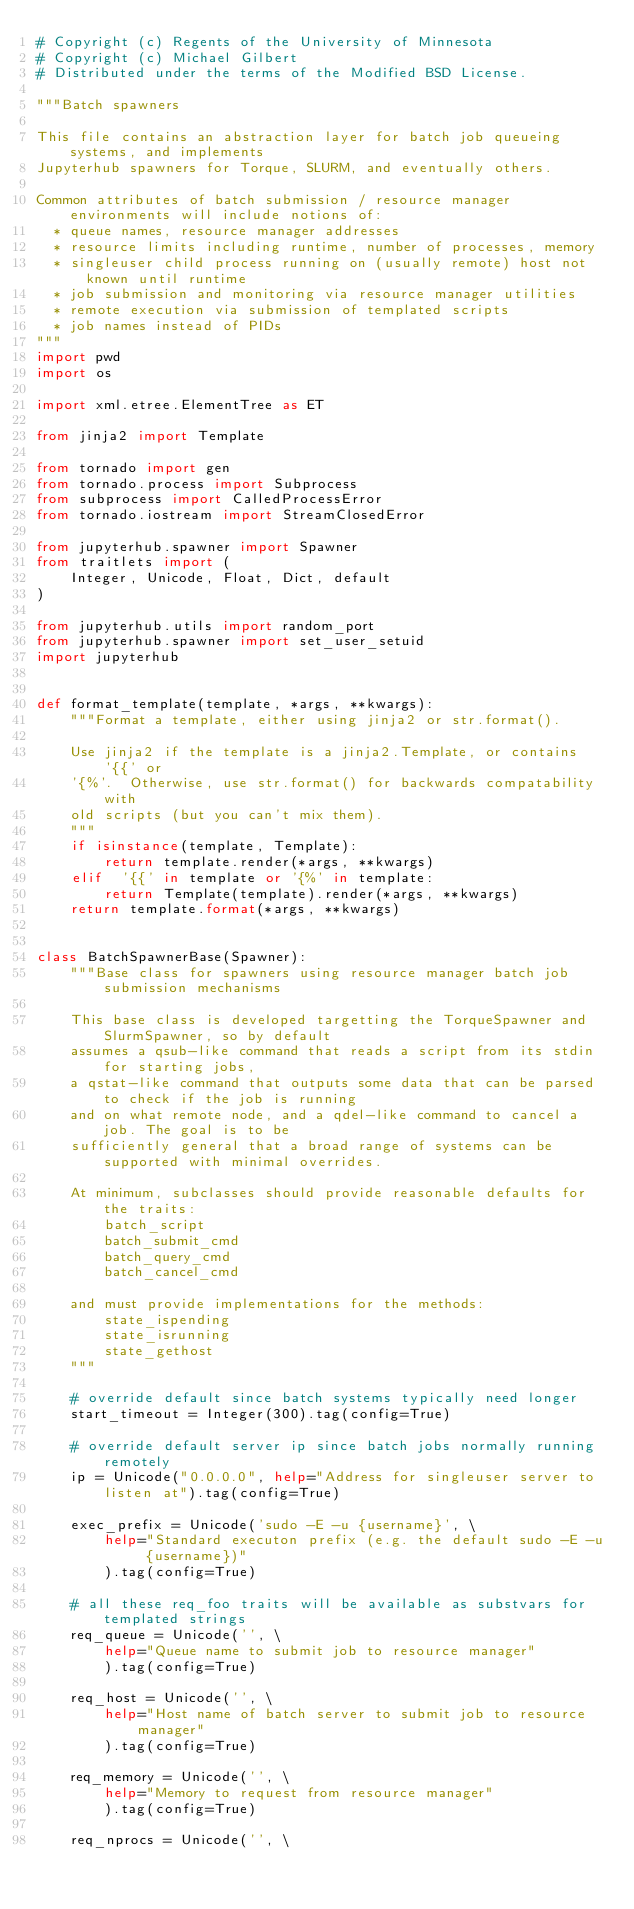<code> <loc_0><loc_0><loc_500><loc_500><_Python_># Copyright (c) Regents of the University of Minnesota
# Copyright (c) Michael Gilbert
# Distributed under the terms of the Modified BSD License.

"""Batch spawners

This file contains an abstraction layer for batch job queueing systems, and implements
Jupyterhub spawners for Torque, SLURM, and eventually others.

Common attributes of batch submission / resource manager environments will include notions of:
  * queue names, resource manager addresses
  * resource limits including runtime, number of processes, memory
  * singleuser child process running on (usually remote) host not known until runtime
  * job submission and monitoring via resource manager utilities
  * remote execution via submission of templated scripts
  * job names instead of PIDs
"""
import pwd
import os

import xml.etree.ElementTree as ET

from jinja2 import Template

from tornado import gen
from tornado.process import Subprocess
from subprocess import CalledProcessError
from tornado.iostream import StreamClosedError

from jupyterhub.spawner import Spawner
from traitlets import (
    Integer, Unicode, Float, Dict, default
)

from jupyterhub.utils import random_port
from jupyterhub.spawner import set_user_setuid
import jupyterhub


def format_template(template, *args, **kwargs):
    """Format a template, either using jinja2 or str.format().

    Use jinja2 if the template is a jinja2.Template, or contains '{{' or
    '{%'.  Otherwise, use str.format() for backwards compatability with
    old scripts (but you can't mix them).
    """
    if isinstance(template, Template):
        return template.render(*args, **kwargs)
    elif  '{{' in template or '{%' in template:
        return Template(template).render(*args, **kwargs)
    return template.format(*args, **kwargs)


class BatchSpawnerBase(Spawner):
    """Base class for spawners using resource manager batch job submission mechanisms

    This base class is developed targetting the TorqueSpawner and SlurmSpawner, so by default
    assumes a qsub-like command that reads a script from its stdin for starting jobs,
    a qstat-like command that outputs some data that can be parsed to check if the job is running
    and on what remote node, and a qdel-like command to cancel a job. The goal is to be
    sufficiently general that a broad range of systems can be supported with minimal overrides.

    At minimum, subclasses should provide reasonable defaults for the traits:
        batch_script
        batch_submit_cmd
        batch_query_cmd
        batch_cancel_cmd

    and must provide implementations for the methods:
        state_ispending
        state_isrunning
        state_gethost
    """

    # override default since batch systems typically need longer
    start_timeout = Integer(300).tag(config=True)

    # override default server ip since batch jobs normally running remotely
    ip = Unicode("0.0.0.0", help="Address for singleuser server to listen at").tag(config=True)

    exec_prefix = Unicode('sudo -E -u {username}', \
        help="Standard executon prefix (e.g. the default sudo -E -u {username})"
        ).tag(config=True)

    # all these req_foo traits will be available as substvars for templated strings
    req_queue = Unicode('', \
        help="Queue name to submit job to resource manager"
        ).tag(config=True)

    req_host = Unicode('', \
        help="Host name of batch server to submit job to resource manager"
        ).tag(config=True)

    req_memory = Unicode('', \
        help="Memory to request from resource manager"
        ).tag(config=True)

    req_nprocs = Unicode('', \</code> 